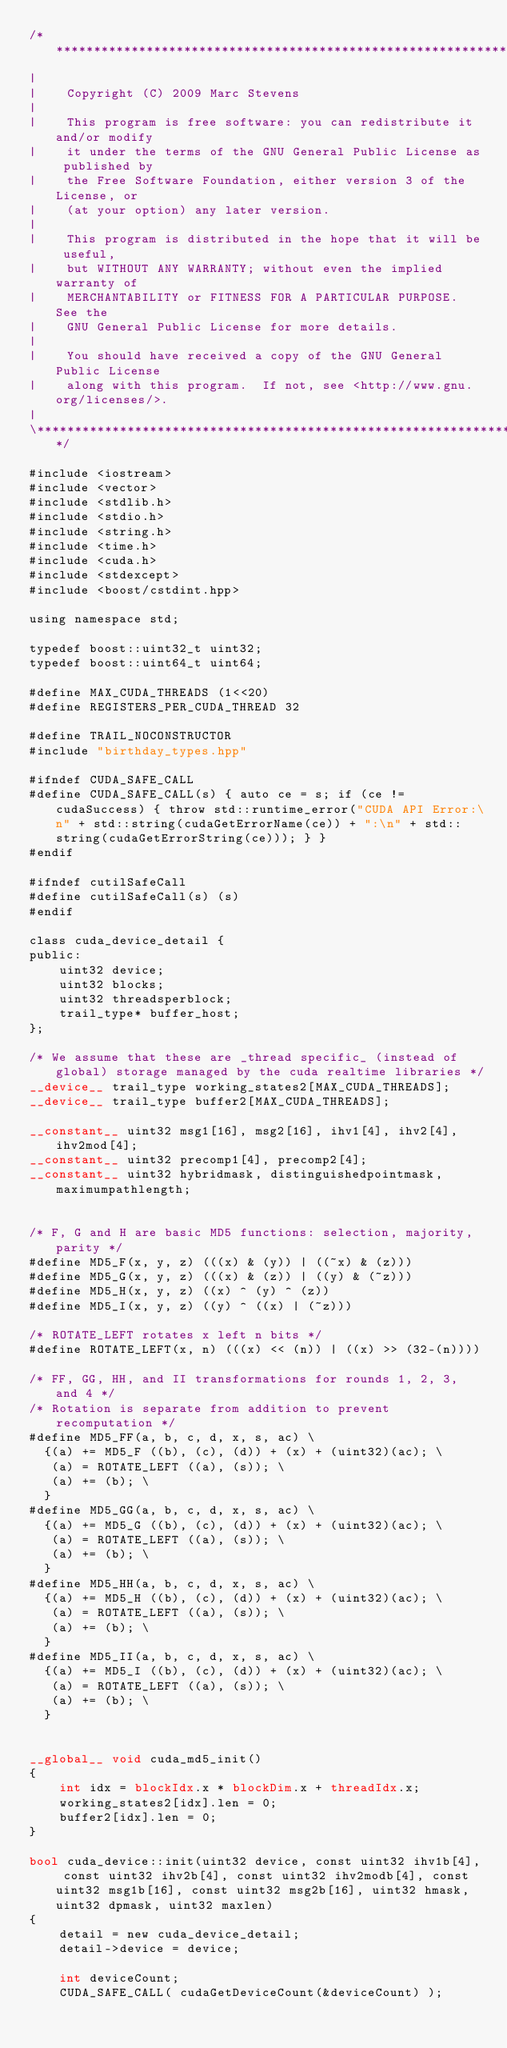Convert code to text. <code><loc_0><loc_0><loc_500><loc_500><_Cuda_>/**************************************************************************\
|
|    Copyright (C) 2009 Marc Stevens
|
|    This program is free software: you can redistribute it and/or modify
|    it under the terms of the GNU General Public License as published by
|    the Free Software Foundation, either version 3 of the License, or
|    (at your option) any later version.
|
|    This program is distributed in the hope that it will be useful,
|    but WITHOUT ANY WARRANTY; without even the implied warranty of
|    MERCHANTABILITY or FITNESS FOR A PARTICULAR PURPOSE.  See the
|    GNU General Public License for more details.
|
|    You should have received a copy of the GNU General Public License
|    along with this program.  If not, see <http://www.gnu.org/licenses/>.
|
\**************************************************************************/

#include <iostream>
#include <vector>
#include <stdlib.h>
#include <stdio.h>
#include <string.h>
#include <time.h>
#include <cuda.h>
#include <stdexcept>
#include <boost/cstdint.hpp>

using namespace std;

typedef boost::uint32_t uint32;
typedef boost::uint64_t uint64;

#define MAX_CUDA_THREADS (1<<20)
#define REGISTERS_PER_CUDA_THREAD 32

#define TRAIL_NOCONSTRUCTOR
#include "birthday_types.hpp"

#ifndef CUDA_SAFE_CALL
#define CUDA_SAFE_CALL(s) { auto ce = s; if (ce != cudaSuccess) { throw std::runtime_error("CUDA API Error:\n" + std::string(cudaGetErrorName(ce)) + ":\n" + std::string(cudaGetErrorString(ce))); } }
#endif

#ifndef cutilSafeCall
#define cutilSafeCall(s) (s)
#endif

class cuda_device_detail {
public:
	uint32 device;
	uint32 blocks;
	uint32 threadsperblock;
	trail_type* buffer_host;
};

/* We assume that these are _thread specific_ (instead of global) storage managed by the cuda realtime libraries */
__device__ trail_type working_states2[MAX_CUDA_THREADS];
__device__ trail_type buffer2[MAX_CUDA_THREADS];

__constant__ uint32 msg1[16], msg2[16], ihv1[4], ihv2[4], ihv2mod[4];
__constant__ uint32 precomp1[4], precomp2[4];
__constant__ uint32 hybridmask, distinguishedpointmask, maximumpathlength;


/* F, G and H are basic MD5 functions: selection, majority, parity */
#define MD5_F(x, y, z) (((x) & (y)) | ((~x) & (z)))
#define MD5_G(x, y, z) (((x) & (z)) | ((y) & (~z)))
#define MD5_H(x, y, z) ((x) ^ (y) ^ (z))
#define MD5_I(x, y, z) ((y) ^ ((x) | (~z)))

/* ROTATE_LEFT rotates x left n bits */
#define ROTATE_LEFT(x, n) (((x) << (n)) | ((x) >> (32-(n))))

/* FF, GG, HH, and II transformations for rounds 1, 2, 3, and 4 */
/* Rotation is separate from addition to prevent recomputation */
#define MD5_FF(a, b, c, d, x, s, ac) \
  {(a) += MD5_F ((b), (c), (d)) + (x) + (uint32)(ac); \
   (a) = ROTATE_LEFT ((a), (s)); \
   (a) += (b); \
  }
#define MD5_GG(a, b, c, d, x, s, ac) \
  {(a) += MD5_G ((b), (c), (d)) + (x) + (uint32)(ac); \
   (a) = ROTATE_LEFT ((a), (s)); \
   (a) += (b); \
  }
#define MD5_HH(a, b, c, d, x, s, ac) \
  {(a) += MD5_H ((b), (c), (d)) + (x) + (uint32)(ac); \
   (a) = ROTATE_LEFT ((a), (s)); \
   (a) += (b); \
  }
#define MD5_II(a, b, c, d, x, s, ac) \
  {(a) += MD5_I ((b), (c), (d)) + (x) + (uint32)(ac); \
   (a) = ROTATE_LEFT ((a), (s)); \
   (a) += (b); \
  }


__global__ void cuda_md5_init()
{
	int idx = blockIdx.x * blockDim.x + threadIdx.x;
	working_states2[idx].len = 0;
	buffer2[idx].len = 0;
}

bool cuda_device::init(uint32 device, const uint32 ihv1b[4], const uint32 ihv2b[4], const uint32 ihv2modb[4], const uint32 msg1b[16], const uint32 msg2b[16], uint32 hmask, uint32 dpmask, uint32 maxlen)
{
	detail = new cuda_device_detail;
	detail->device = device;

    int deviceCount;
    CUDA_SAFE_CALL( cudaGetDeviceCount(&deviceCount) );</code> 